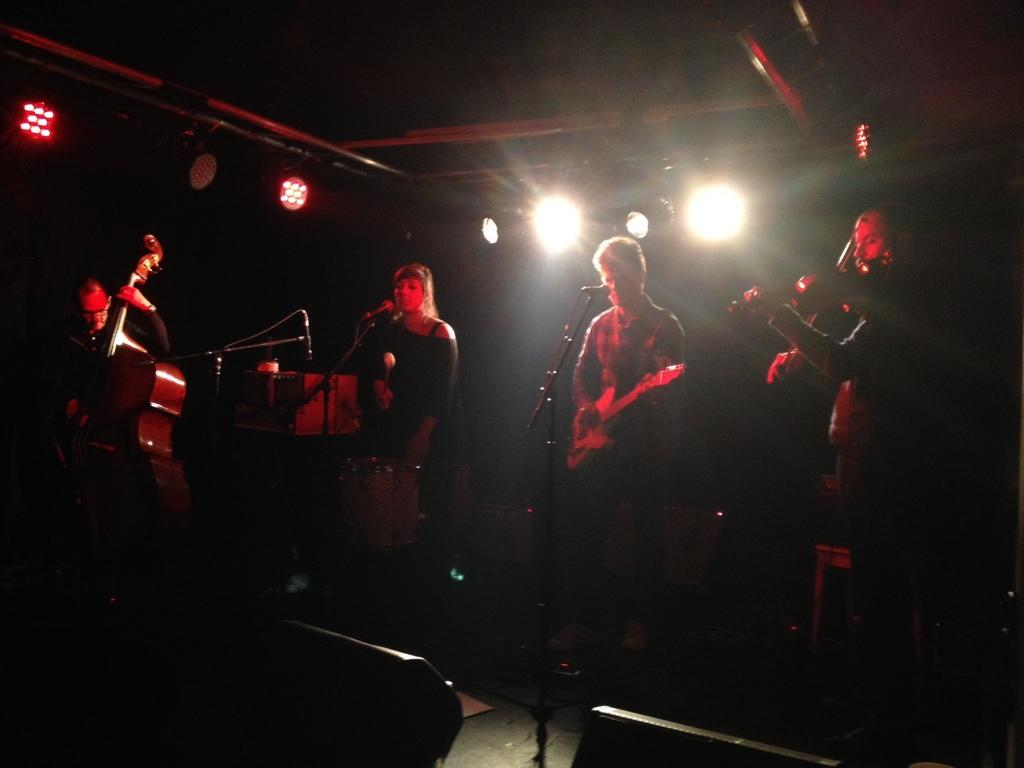How many people are in the image? There are four members in the image. What are three of them doing in the image? Three of them are playing musical instruments. Can you describe the background of the image? There are two lights in the background of the image. What type of food is being served by the maid in the image? There is no maid or food present in the image; it features four people, three of whom are playing musical instruments. 